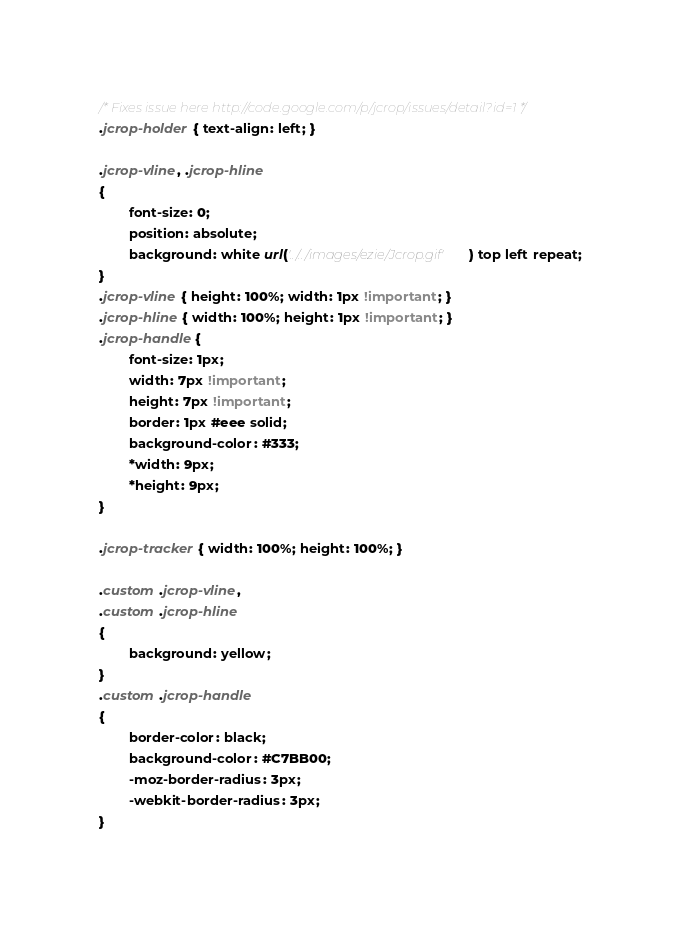<code> <loc_0><loc_0><loc_500><loc_500><_CSS_>/* Fixes issue here http://code.google.com/p/jcrop/issues/detail?id=1 */
.jcrop-holder { text-align: left; }

.jcrop-vline, .jcrop-hline
{
        font-size: 0;
        position: absolute;
        background: white url('../../images/ezie/Jcrop.gif') top left repeat;
}
.jcrop-vline { height: 100%; width: 1px !important; }
.jcrop-hline { width: 100%; height: 1px !important; }
.jcrop-handle {
        font-size: 1px;
        width: 7px !important;
        height: 7px !important;
        border: 1px #eee solid;
        background-color: #333;
        *width: 9px;
        *height: 9px;
}

.jcrop-tracker { width: 100%; height: 100%; }

.custom .jcrop-vline,
.custom .jcrop-hline
{
        background: yellow;
}
.custom .jcrop-handle
{
        border-color: black;
        background-color: #C7BB00;
        -moz-border-radius: 3px;
        -webkit-border-radius: 3px;
}
</code> 